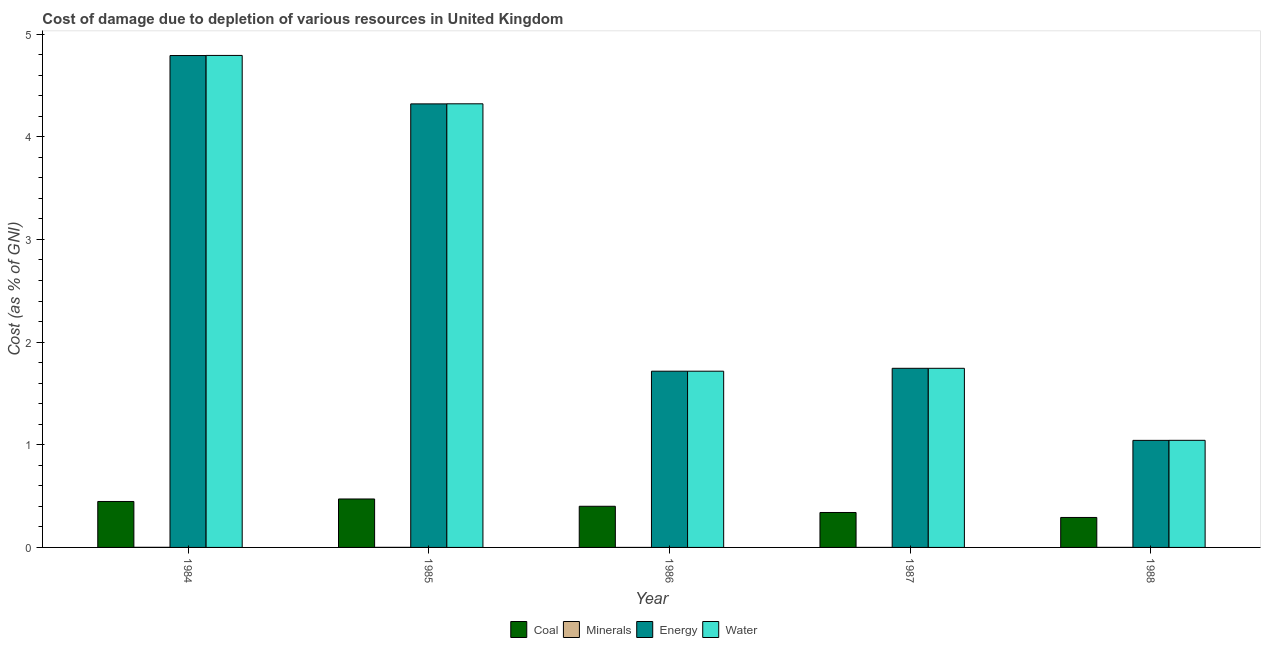How many groups of bars are there?
Make the answer very short. 5. Are the number of bars per tick equal to the number of legend labels?
Keep it short and to the point. Yes. Are the number of bars on each tick of the X-axis equal?
Offer a very short reply. Yes. How many bars are there on the 1st tick from the left?
Make the answer very short. 4. What is the label of the 2nd group of bars from the left?
Provide a succinct answer. 1985. What is the cost of damage due to depletion of coal in 1985?
Provide a short and direct response. 0.47. Across all years, what is the maximum cost of damage due to depletion of water?
Provide a succinct answer. 4.79. Across all years, what is the minimum cost of damage due to depletion of minerals?
Your answer should be very brief. 1.58362558914739e-5. In which year was the cost of damage due to depletion of minerals maximum?
Your answer should be very brief. 1984. What is the total cost of damage due to depletion of water in the graph?
Your answer should be compact. 13.62. What is the difference between the cost of damage due to depletion of water in 1987 and that in 1988?
Make the answer very short. 0.7. What is the difference between the cost of damage due to depletion of minerals in 1986 and the cost of damage due to depletion of coal in 1987?
Make the answer very short. -2.7994997032664813e-5. What is the average cost of damage due to depletion of energy per year?
Provide a short and direct response. 2.72. In the year 1985, what is the difference between the cost of damage due to depletion of water and cost of damage due to depletion of coal?
Provide a succinct answer. 0. What is the ratio of the cost of damage due to depletion of energy in 1987 to that in 1988?
Ensure brevity in your answer.  1.67. Is the cost of damage due to depletion of energy in 1984 less than that in 1985?
Keep it short and to the point. No. Is the difference between the cost of damage due to depletion of water in 1984 and 1987 greater than the difference between the cost of damage due to depletion of coal in 1984 and 1987?
Ensure brevity in your answer.  No. What is the difference between the highest and the second highest cost of damage due to depletion of water?
Your response must be concise. 0.47. What is the difference between the highest and the lowest cost of damage due to depletion of coal?
Make the answer very short. 0.18. In how many years, is the cost of damage due to depletion of water greater than the average cost of damage due to depletion of water taken over all years?
Keep it short and to the point. 2. Is the sum of the cost of damage due to depletion of water in 1985 and 1986 greater than the maximum cost of damage due to depletion of energy across all years?
Ensure brevity in your answer.  Yes. Is it the case that in every year, the sum of the cost of damage due to depletion of minerals and cost of damage due to depletion of energy is greater than the sum of cost of damage due to depletion of water and cost of damage due to depletion of coal?
Your answer should be compact. No. What does the 3rd bar from the left in 1984 represents?
Make the answer very short. Energy. What does the 4th bar from the right in 1984 represents?
Provide a short and direct response. Coal. How many bars are there?
Your response must be concise. 20. Are all the bars in the graph horizontal?
Your response must be concise. No. Where does the legend appear in the graph?
Ensure brevity in your answer.  Bottom center. What is the title of the graph?
Ensure brevity in your answer.  Cost of damage due to depletion of various resources in United Kingdom . Does "Financial sector" appear as one of the legend labels in the graph?
Your answer should be very brief. No. What is the label or title of the X-axis?
Provide a short and direct response. Year. What is the label or title of the Y-axis?
Offer a very short reply. Cost (as % of GNI). What is the Cost (as % of GNI) in Coal in 1984?
Offer a terse response. 0.45. What is the Cost (as % of GNI) of Minerals in 1984?
Provide a succinct answer. 0. What is the Cost (as % of GNI) in Energy in 1984?
Offer a terse response. 4.79. What is the Cost (as % of GNI) in Water in 1984?
Your answer should be very brief. 4.79. What is the Cost (as % of GNI) of Coal in 1985?
Your response must be concise. 0.47. What is the Cost (as % of GNI) of Minerals in 1985?
Make the answer very short. 0. What is the Cost (as % of GNI) in Energy in 1985?
Offer a very short reply. 4.32. What is the Cost (as % of GNI) of Water in 1985?
Keep it short and to the point. 4.32. What is the Cost (as % of GNI) of Coal in 1986?
Provide a short and direct response. 0.4. What is the Cost (as % of GNI) of Minerals in 1986?
Your answer should be compact. 1.58362558914739e-5. What is the Cost (as % of GNI) in Energy in 1986?
Make the answer very short. 1.72. What is the Cost (as % of GNI) in Water in 1986?
Your answer should be compact. 1.72. What is the Cost (as % of GNI) of Coal in 1987?
Give a very brief answer. 0.34. What is the Cost (as % of GNI) in Minerals in 1987?
Give a very brief answer. 4.383125292413871e-5. What is the Cost (as % of GNI) in Energy in 1987?
Give a very brief answer. 1.74. What is the Cost (as % of GNI) of Water in 1987?
Provide a succinct answer. 1.74. What is the Cost (as % of GNI) of Coal in 1988?
Make the answer very short. 0.29. What is the Cost (as % of GNI) of Minerals in 1988?
Give a very brief answer. 0. What is the Cost (as % of GNI) in Energy in 1988?
Offer a terse response. 1.04. What is the Cost (as % of GNI) of Water in 1988?
Make the answer very short. 1.04. Across all years, what is the maximum Cost (as % of GNI) in Coal?
Your answer should be very brief. 0.47. Across all years, what is the maximum Cost (as % of GNI) of Minerals?
Offer a very short reply. 0. Across all years, what is the maximum Cost (as % of GNI) of Energy?
Your answer should be compact. 4.79. Across all years, what is the maximum Cost (as % of GNI) of Water?
Provide a short and direct response. 4.79. Across all years, what is the minimum Cost (as % of GNI) of Coal?
Provide a short and direct response. 0.29. Across all years, what is the minimum Cost (as % of GNI) in Minerals?
Offer a very short reply. 1.58362558914739e-5. Across all years, what is the minimum Cost (as % of GNI) in Energy?
Your answer should be very brief. 1.04. Across all years, what is the minimum Cost (as % of GNI) of Water?
Offer a very short reply. 1.04. What is the total Cost (as % of GNI) in Coal in the graph?
Your answer should be very brief. 1.95. What is the total Cost (as % of GNI) of Minerals in the graph?
Your response must be concise. 0. What is the total Cost (as % of GNI) in Energy in the graph?
Your answer should be compact. 13.61. What is the total Cost (as % of GNI) of Water in the graph?
Your answer should be compact. 13.62. What is the difference between the Cost (as % of GNI) in Coal in 1984 and that in 1985?
Provide a short and direct response. -0.02. What is the difference between the Cost (as % of GNI) in Minerals in 1984 and that in 1985?
Keep it short and to the point. 0. What is the difference between the Cost (as % of GNI) of Energy in 1984 and that in 1985?
Your answer should be very brief. 0.47. What is the difference between the Cost (as % of GNI) of Water in 1984 and that in 1985?
Provide a short and direct response. 0.47. What is the difference between the Cost (as % of GNI) of Coal in 1984 and that in 1986?
Provide a succinct answer. 0.05. What is the difference between the Cost (as % of GNI) of Energy in 1984 and that in 1986?
Provide a succinct answer. 3.07. What is the difference between the Cost (as % of GNI) in Water in 1984 and that in 1986?
Provide a succinct answer. 3.08. What is the difference between the Cost (as % of GNI) of Coal in 1984 and that in 1987?
Provide a short and direct response. 0.11. What is the difference between the Cost (as % of GNI) in Minerals in 1984 and that in 1987?
Provide a succinct answer. 0. What is the difference between the Cost (as % of GNI) of Energy in 1984 and that in 1987?
Your answer should be compact. 3.05. What is the difference between the Cost (as % of GNI) of Water in 1984 and that in 1987?
Give a very brief answer. 3.05. What is the difference between the Cost (as % of GNI) of Coal in 1984 and that in 1988?
Your response must be concise. 0.16. What is the difference between the Cost (as % of GNI) of Minerals in 1984 and that in 1988?
Provide a succinct answer. 0. What is the difference between the Cost (as % of GNI) of Energy in 1984 and that in 1988?
Your response must be concise. 3.75. What is the difference between the Cost (as % of GNI) in Water in 1984 and that in 1988?
Your answer should be compact. 3.75. What is the difference between the Cost (as % of GNI) in Coal in 1985 and that in 1986?
Give a very brief answer. 0.07. What is the difference between the Cost (as % of GNI) of Minerals in 1985 and that in 1986?
Your response must be concise. 0. What is the difference between the Cost (as % of GNI) of Energy in 1985 and that in 1986?
Ensure brevity in your answer.  2.6. What is the difference between the Cost (as % of GNI) of Water in 1985 and that in 1986?
Provide a short and direct response. 2.6. What is the difference between the Cost (as % of GNI) of Coal in 1985 and that in 1987?
Keep it short and to the point. 0.13. What is the difference between the Cost (as % of GNI) of Minerals in 1985 and that in 1987?
Keep it short and to the point. 0. What is the difference between the Cost (as % of GNI) in Energy in 1985 and that in 1987?
Ensure brevity in your answer.  2.58. What is the difference between the Cost (as % of GNI) in Water in 1985 and that in 1987?
Provide a succinct answer. 2.58. What is the difference between the Cost (as % of GNI) of Coal in 1985 and that in 1988?
Offer a very short reply. 0.18. What is the difference between the Cost (as % of GNI) of Energy in 1985 and that in 1988?
Offer a very short reply. 3.28. What is the difference between the Cost (as % of GNI) of Water in 1985 and that in 1988?
Your answer should be compact. 3.28. What is the difference between the Cost (as % of GNI) in Coal in 1986 and that in 1987?
Offer a terse response. 0.06. What is the difference between the Cost (as % of GNI) in Minerals in 1986 and that in 1987?
Your answer should be compact. -0. What is the difference between the Cost (as % of GNI) in Energy in 1986 and that in 1987?
Offer a terse response. -0.03. What is the difference between the Cost (as % of GNI) in Water in 1986 and that in 1987?
Provide a short and direct response. -0.03. What is the difference between the Cost (as % of GNI) in Coal in 1986 and that in 1988?
Keep it short and to the point. 0.11. What is the difference between the Cost (as % of GNI) in Minerals in 1986 and that in 1988?
Keep it short and to the point. -0. What is the difference between the Cost (as % of GNI) in Energy in 1986 and that in 1988?
Give a very brief answer. 0.67. What is the difference between the Cost (as % of GNI) of Water in 1986 and that in 1988?
Provide a short and direct response. 0.67. What is the difference between the Cost (as % of GNI) of Coal in 1987 and that in 1988?
Your response must be concise. 0.05. What is the difference between the Cost (as % of GNI) in Minerals in 1987 and that in 1988?
Make the answer very short. -0. What is the difference between the Cost (as % of GNI) of Energy in 1987 and that in 1988?
Your answer should be compact. 0.7. What is the difference between the Cost (as % of GNI) in Water in 1987 and that in 1988?
Ensure brevity in your answer.  0.7. What is the difference between the Cost (as % of GNI) in Coal in 1984 and the Cost (as % of GNI) in Minerals in 1985?
Keep it short and to the point. 0.45. What is the difference between the Cost (as % of GNI) in Coal in 1984 and the Cost (as % of GNI) in Energy in 1985?
Offer a terse response. -3.87. What is the difference between the Cost (as % of GNI) in Coal in 1984 and the Cost (as % of GNI) in Water in 1985?
Your response must be concise. -3.87. What is the difference between the Cost (as % of GNI) of Minerals in 1984 and the Cost (as % of GNI) of Energy in 1985?
Ensure brevity in your answer.  -4.32. What is the difference between the Cost (as % of GNI) of Minerals in 1984 and the Cost (as % of GNI) of Water in 1985?
Give a very brief answer. -4.32. What is the difference between the Cost (as % of GNI) of Energy in 1984 and the Cost (as % of GNI) of Water in 1985?
Offer a terse response. 0.47. What is the difference between the Cost (as % of GNI) of Coal in 1984 and the Cost (as % of GNI) of Minerals in 1986?
Keep it short and to the point. 0.45. What is the difference between the Cost (as % of GNI) of Coal in 1984 and the Cost (as % of GNI) of Energy in 1986?
Give a very brief answer. -1.27. What is the difference between the Cost (as % of GNI) in Coal in 1984 and the Cost (as % of GNI) in Water in 1986?
Offer a terse response. -1.27. What is the difference between the Cost (as % of GNI) of Minerals in 1984 and the Cost (as % of GNI) of Energy in 1986?
Your response must be concise. -1.72. What is the difference between the Cost (as % of GNI) of Minerals in 1984 and the Cost (as % of GNI) of Water in 1986?
Offer a very short reply. -1.72. What is the difference between the Cost (as % of GNI) in Energy in 1984 and the Cost (as % of GNI) in Water in 1986?
Keep it short and to the point. 3.07. What is the difference between the Cost (as % of GNI) of Coal in 1984 and the Cost (as % of GNI) of Minerals in 1987?
Your answer should be very brief. 0.45. What is the difference between the Cost (as % of GNI) of Coal in 1984 and the Cost (as % of GNI) of Energy in 1987?
Provide a succinct answer. -1.3. What is the difference between the Cost (as % of GNI) in Coal in 1984 and the Cost (as % of GNI) in Water in 1987?
Give a very brief answer. -1.3. What is the difference between the Cost (as % of GNI) in Minerals in 1984 and the Cost (as % of GNI) in Energy in 1987?
Provide a short and direct response. -1.74. What is the difference between the Cost (as % of GNI) in Minerals in 1984 and the Cost (as % of GNI) in Water in 1987?
Ensure brevity in your answer.  -1.74. What is the difference between the Cost (as % of GNI) of Energy in 1984 and the Cost (as % of GNI) of Water in 1987?
Offer a very short reply. 3.05. What is the difference between the Cost (as % of GNI) of Coal in 1984 and the Cost (as % of GNI) of Minerals in 1988?
Provide a short and direct response. 0.45. What is the difference between the Cost (as % of GNI) in Coal in 1984 and the Cost (as % of GNI) in Energy in 1988?
Keep it short and to the point. -0.6. What is the difference between the Cost (as % of GNI) in Coal in 1984 and the Cost (as % of GNI) in Water in 1988?
Your answer should be very brief. -0.6. What is the difference between the Cost (as % of GNI) of Minerals in 1984 and the Cost (as % of GNI) of Energy in 1988?
Give a very brief answer. -1.04. What is the difference between the Cost (as % of GNI) of Minerals in 1984 and the Cost (as % of GNI) of Water in 1988?
Offer a very short reply. -1.04. What is the difference between the Cost (as % of GNI) of Energy in 1984 and the Cost (as % of GNI) of Water in 1988?
Ensure brevity in your answer.  3.75. What is the difference between the Cost (as % of GNI) of Coal in 1985 and the Cost (as % of GNI) of Minerals in 1986?
Keep it short and to the point. 0.47. What is the difference between the Cost (as % of GNI) of Coal in 1985 and the Cost (as % of GNI) of Energy in 1986?
Your answer should be very brief. -1.24. What is the difference between the Cost (as % of GNI) in Coal in 1985 and the Cost (as % of GNI) in Water in 1986?
Your response must be concise. -1.24. What is the difference between the Cost (as % of GNI) in Minerals in 1985 and the Cost (as % of GNI) in Energy in 1986?
Your answer should be very brief. -1.72. What is the difference between the Cost (as % of GNI) of Minerals in 1985 and the Cost (as % of GNI) of Water in 1986?
Provide a succinct answer. -1.72. What is the difference between the Cost (as % of GNI) of Energy in 1985 and the Cost (as % of GNI) of Water in 1986?
Offer a terse response. 2.6. What is the difference between the Cost (as % of GNI) in Coal in 1985 and the Cost (as % of GNI) in Minerals in 1987?
Offer a terse response. 0.47. What is the difference between the Cost (as % of GNI) in Coal in 1985 and the Cost (as % of GNI) in Energy in 1987?
Make the answer very short. -1.27. What is the difference between the Cost (as % of GNI) in Coal in 1985 and the Cost (as % of GNI) in Water in 1987?
Offer a very short reply. -1.27. What is the difference between the Cost (as % of GNI) in Minerals in 1985 and the Cost (as % of GNI) in Energy in 1987?
Offer a very short reply. -1.74. What is the difference between the Cost (as % of GNI) of Minerals in 1985 and the Cost (as % of GNI) of Water in 1987?
Offer a terse response. -1.74. What is the difference between the Cost (as % of GNI) in Energy in 1985 and the Cost (as % of GNI) in Water in 1987?
Offer a very short reply. 2.58. What is the difference between the Cost (as % of GNI) in Coal in 1985 and the Cost (as % of GNI) in Minerals in 1988?
Your answer should be compact. 0.47. What is the difference between the Cost (as % of GNI) in Coal in 1985 and the Cost (as % of GNI) in Energy in 1988?
Offer a very short reply. -0.57. What is the difference between the Cost (as % of GNI) in Coal in 1985 and the Cost (as % of GNI) in Water in 1988?
Your response must be concise. -0.57. What is the difference between the Cost (as % of GNI) in Minerals in 1985 and the Cost (as % of GNI) in Energy in 1988?
Provide a short and direct response. -1.04. What is the difference between the Cost (as % of GNI) of Minerals in 1985 and the Cost (as % of GNI) of Water in 1988?
Offer a very short reply. -1.04. What is the difference between the Cost (as % of GNI) in Energy in 1985 and the Cost (as % of GNI) in Water in 1988?
Your answer should be compact. 3.28. What is the difference between the Cost (as % of GNI) in Coal in 1986 and the Cost (as % of GNI) in Minerals in 1987?
Offer a very short reply. 0.4. What is the difference between the Cost (as % of GNI) of Coal in 1986 and the Cost (as % of GNI) of Energy in 1987?
Offer a terse response. -1.34. What is the difference between the Cost (as % of GNI) in Coal in 1986 and the Cost (as % of GNI) in Water in 1987?
Offer a terse response. -1.34. What is the difference between the Cost (as % of GNI) of Minerals in 1986 and the Cost (as % of GNI) of Energy in 1987?
Your answer should be very brief. -1.74. What is the difference between the Cost (as % of GNI) of Minerals in 1986 and the Cost (as % of GNI) of Water in 1987?
Provide a short and direct response. -1.74. What is the difference between the Cost (as % of GNI) of Energy in 1986 and the Cost (as % of GNI) of Water in 1987?
Give a very brief answer. -0.03. What is the difference between the Cost (as % of GNI) of Coal in 1986 and the Cost (as % of GNI) of Minerals in 1988?
Your response must be concise. 0.4. What is the difference between the Cost (as % of GNI) of Coal in 1986 and the Cost (as % of GNI) of Energy in 1988?
Provide a short and direct response. -0.64. What is the difference between the Cost (as % of GNI) in Coal in 1986 and the Cost (as % of GNI) in Water in 1988?
Ensure brevity in your answer.  -0.64. What is the difference between the Cost (as % of GNI) in Minerals in 1986 and the Cost (as % of GNI) in Energy in 1988?
Provide a short and direct response. -1.04. What is the difference between the Cost (as % of GNI) of Minerals in 1986 and the Cost (as % of GNI) of Water in 1988?
Offer a very short reply. -1.04. What is the difference between the Cost (as % of GNI) in Energy in 1986 and the Cost (as % of GNI) in Water in 1988?
Give a very brief answer. 0.67. What is the difference between the Cost (as % of GNI) in Coal in 1987 and the Cost (as % of GNI) in Minerals in 1988?
Your answer should be compact. 0.34. What is the difference between the Cost (as % of GNI) of Coal in 1987 and the Cost (as % of GNI) of Energy in 1988?
Make the answer very short. -0.7. What is the difference between the Cost (as % of GNI) of Coal in 1987 and the Cost (as % of GNI) of Water in 1988?
Provide a succinct answer. -0.7. What is the difference between the Cost (as % of GNI) in Minerals in 1987 and the Cost (as % of GNI) in Energy in 1988?
Provide a short and direct response. -1.04. What is the difference between the Cost (as % of GNI) in Minerals in 1987 and the Cost (as % of GNI) in Water in 1988?
Provide a succinct answer. -1.04. What is the difference between the Cost (as % of GNI) of Energy in 1987 and the Cost (as % of GNI) of Water in 1988?
Provide a succinct answer. 0.7. What is the average Cost (as % of GNI) in Coal per year?
Give a very brief answer. 0.39. What is the average Cost (as % of GNI) in Energy per year?
Your answer should be compact. 2.72. What is the average Cost (as % of GNI) of Water per year?
Offer a very short reply. 2.72. In the year 1984, what is the difference between the Cost (as % of GNI) in Coal and Cost (as % of GNI) in Minerals?
Offer a very short reply. 0.45. In the year 1984, what is the difference between the Cost (as % of GNI) in Coal and Cost (as % of GNI) in Energy?
Keep it short and to the point. -4.34. In the year 1984, what is the difference between the Cost (as % of GNI) of Coal and Cost (as % of GNI) of Water?
Your response must be concise. -4.34. In the year 1984, what is the difference between the Cost (as % of GNI) in Minerals and Cost (as % of GNI) in Energy?
Give a very brief answer. -4.79. In the year 1984, what is the difference between the Cost (as % of GNI) of Minerals and Cost (as % of GNI) of Water?
Your answer should be very brief. -4.79. In the year 1984, what is the difference between the Cost (as % of GNI) of Energy and Cost (as % of GNI) of Water?
Offer a terse response. -0. In the year 1985, what is the difference between the Cost (as % of GNI) of Coal and Cost (as % of GNI) of Minerals?
Offer a terse response. 0.47. In the year 1985, what is the difference between the Cost (as % of GNI) of Coal and Cost (as % of GNI) of Energy?
Give a very brief answer. -3.85. In the year 1985, what is the difference between the Cost (as % of GNI) in Coal and Cost (as % of GNI) in Water?
Provide a short and direct response. -3.85. In the year 1985, what is the difference between the Cost (as % of GNI) in Minerals and Cost (as % of GNI) in Energy?
Your response must be concise. -4.32. In the year 1985, what is the difference between the Cost (as % of GNI) in Minerals and Cost (as % of GNI) in Water?
Provide a succinct answer. -4.32. In the year 1985, what is the difference between the Cost (as % of GNI) in Energy and Cost (as % of GNI) in Water?
Give a very brief answer. -0. In the year 1986, what is the difference between the Cost (as % of GNI) of Coal and Cost (as % of GNI) of Minerals?
Your answer should be very brief. 0.4. In the year 1986, what is the difference between the Cost (as % of GNI) of Coal and Cost (as % of GNI) of Energy?
Your answer should be compact. -1.32. In the year 1986, what is the difference between the Cost (as % of GNI) of Coal and Cost (as % of GNI) of Water?
Your response must be concise. -1.32. In the year 1986, what is the difference between the Cost (as % of GNI) of Minerals and Cost (as % of GNI) of Energy?
Your response must be concise. -1.72. In the year 1986, what is the difference between the Cost (as % of GNI) in Minerals and Cost (as % of GNI) in Water?
Give a very brief answer. -1.72. In the year 1987, what is the difference between the Cost (as % of GNI) of Coal and Cost (as % of GNI) of Minerals?
Ensure brevity in your answer.  0.34. In the year 1987, what is the difference between the Cost (as % of GNI) of Coal and Cost (as % of GNI) of Energy?
Offer a terse response. -1.4. In the year 1987, what is the difference between the Cost (as % of GNI) in Coal and Cost (as % of GNI) in Water?
Ensure brevity in your answer.  -1.4. In the year 1987, what is the difference between the Cost (as % of GNI) in Minerals and Cost (as % of GNI) in Energy?
Offer a very short reply. -1.74. In the year 1987, what is the difference between the Cost (as % of GNI) in Minerals and Cost (as % of GNI) in Water?
Ensure brevity in your answer.  -1.74. In the year 1987, what is the difference between the Cost (as % of GNI) in Energy and Cost (as % of GNI) in Water?
Keep it short and to the point. -0. In the year 1988, what is the difference between the Cost (as % of GNI) in Coal and Cost (as % of GNI) in Minerals?
Offer a terse response. 0.29. In the year 1988, what is the difference between the Cost (as % of GNI) in Coal and Cost (as % of GNI) in Energy?
Provide a succinct answer. -0.75. In the year 1988, what is the difference between the Cost (as % of GNI) in Coal and Cost (as % of GNI) in Water?
Your response must be concise. -0.75. In the year 1988, what is the difference between the Cost (as % of GNI) in Minerals and Cost (as % of GNI) in Energy?
Your response must be concise. -1.04. In the year 1988, what is the difference between the Cost (as % of GNI) of Minerals and Cost (as % of GNI) of Water?
Provide a short and direct response. -1.04. In the year 1988, what is the difference between the Cost (as % of GNI) in Energy and Cost (as % of GNI) in Water?
Provide a short and direct response. -0. What is the ratio of the Cost (as % of GNI) of Coal in 1984 to that in 1985?
Your response must be concise. 0.95. What is the ratio of the Cost (as % of GNI) in Minerals in 1984 to that in 1985?
Keep it short and to the point. 1.46. What is the ratio of the Cost (as % of GNI) of Energy in 1984 to that in 1985?
Offer a terse response. 1.11. What is the ratio of the Cost (as % of GNI) of Water in 1984 to that in 1985?
Make the answer very short. 1.11. What is the ratio of the Cost (as % of GNI) of Coal in 1984 to that in 1986?
Offer a very short reply. 1.12. What is the ratio of the Cost (as % of GNI) of Minerals in 1984 to that in 1986?
Your response must be concise. 67.26. What is the ratio of the Cost (as % of GNI) of Energy in 1984 to that in 1986?
Your answer should be very brief. 2.79. What is the ratio of the Cost (as % of GNI) in Water in 1984 to that in 1986?
Ensure brevity in your answer.  2.79. What is the ratio of the Cost (as % of GNI) of Coal in 1984 to that in 1987?
Offer a terse response. 1.32. What is the ratio of the Cost (as % of GNI) of Minerals in 1984 to that in 1987?
Keep it short and to the point. 24.3. What is the ratio of the Cost (as % of GNI) of Energy in 1984 to that in 1987?
Your answer should be compact. 2.75. What is the ratio of the Cost (as % of GNI) of Water in 1984 to that in 1987?
Provide a short and direct response. 2.75. What is the ratio of the Cost (as % of GNI) in Coal in 1984 to that in 1988?
Your answer should be compact. 1.53. What is the ratio of the Cost (as % of GNI) of Minerals in 1984 to that in 1988?
Your response must be concise. 2.76. What is the ratio of the Cost (as % of GNI) of Energy in 1984 to that in 1988?
Provide a short and direct response. 4.59. What is the ratio of the Cost (as % of GNI) of Water in 1984 to that in 1988?
Keep it short and to the point. 4.59. What is the ratio of the Cost (as % of GNI) of Coal in 1985 to that in 1986?
Make the answer very short. 1.18. What is the ratio of the Cost (as % of GNI) of Minerals in 1985 to that in 1986?
Your response must be concise. 45.92. What is the ratio of the Cost (as % of GNI) in Energy in 1985 to that in 1986?
Provide a succinct answer. 2.52. What is the ratio of the Cost (as % of GNI) in Water in 1985 to that in 1986?
Your response must be concise. 2.52. What is the ratio of the Cost (as % of GNI) in Coal in 1985 to that in 1987?
Your response must be concise. 1.39. What is the ratio of the Cost (as % of GNI) in Minerals in 1985 to that in 1987?
Keep it short and to the point. 16.59. What is the ratio of the Cost (as % of GNI) in Energy in 1985 to that in 1987?
Offer a terse response. 2.48. What is the ratio of the Cost (as % of GNI) of Water in 1985 to that in 1987?
Give a very brief answer. 2.48. What is the ratio of the Cost (as % of GNI) in Coal in 1985 to that in 1988?
Your answer should be very brief. 1.62. What is the ratio of the Cost (as % of GNI) of Minerals in 1985 to that in 1988?
Provide a short and direct response. 1.89. What is the ratio of the Cost (as % of GNI) in Energy in 1985 to that in 1988?
Provide a succinct answer. 4.14. What is the ratio of the Cost (as % of GNI) in Water in 1985 to that in 1988?
Offer a very short reply. 4.14. What is the ratio of the Cost (as % of GNI) in Coal in 1986 to that in 1987?
Your answer should be very brief. 1.18. What is the ratio of the Cost (as % of GNI) in Minerals in 1986 to that in 1987?
Keep it short and to the point. 0.36. What is the ratio of the Cost (as % of GNI) in Energy in 1986 to that in 1987?
Your answer should be very brief. 0.98. What is the ratio of the Cost (as % of GNI) in Water in 1986 to that in 1987?
Provide a short and direct response. 0.98. What is the ratio of the Cost (as % of GNI) of Coal in 1986 to that in 1988?
Your answer should be compact. 1.37. What is the ratio of the Cost (as % of GNI) of Minerals in 1986 to that in 1988?
Provide a succinct answer. 0.04. What is the ratio of the Cost (as % of GNI) in Energy in 1986 to that in 1988?
Make the answer very short. 1.65. What is the ratio of the Cost (as % of GNI) of Water in 1986 to that in 1988?
Your answer should be very brief. 1.65. What is the ratio of the Cost (as % of GNI) of Coal in 1987 to that in 1988?
Offer a very short reply. 1.17. What is the ratio of the Cost (as % of GNI) in Minerals in 1987 to that in 1988?
Make the answer very short. 0.11. What is the ratio of the Cost (as % of GNI) in Energy in 1987 to that in 1988?
Your answer should be very brief. 1.67. What is the ratio of the Cost (as % of GNI) of Water in 1987 to that in 1988?
Keep it short and to the point. 1.67. What is the difference between the highest and the second highest Cost (as % of GNI) of Coal?
Your response must be concise. 0.02. What is the difference between the highest and the second highest Cost (as % of GNI) in Energy?
Offer a terse response. 0.47. What is the difference between the highest and the second highest Cost (as % of GNI) of Water?
Offer a very short reply. 0.47. What is the difference between the highest and the lowest Cost (as % of GNI) in Coal?
Give a very brief answer. 0.18. What is the difference between the highest and the lowest Cost (as % of GNI) of Minerals?
Ensure brevity in your answer.  0. What is the difference between the highest and the lowest Cost (as % of GNI) of Energy?
Give a very brief answer. 3.75. What is the difference between the highest and the lowest Cost (as % of GNI) of Water?
Provide a succinct answer. 3.75. 